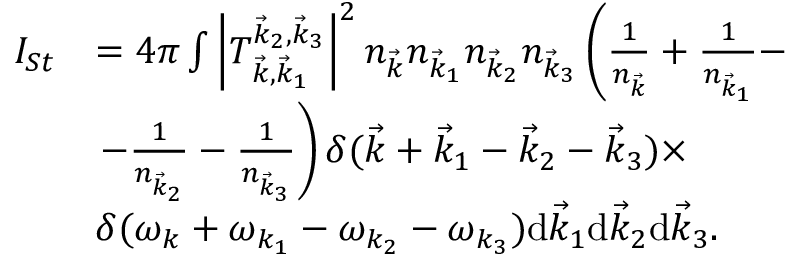Convert formula to latex. <formula><loc_0><loc_0><loc_500><loc_500>\begin{array} { r l } { I _ { S t } } & { = 4 \pi \int \left | T _ { \vec { k } , \vec { k } _ { 1 } } ^ { \vec { k } _ { 2 } , \vec { k } _ { 3 } } \right | ^ { 2 } n _ { \vec { k } } n _ { \vec { k } _ { 1 } } n _ { \vec { k } _ { 2 } } n _ { \vec { k } _ { 3 } } \left ( \frac { 1 } { n _ { \vec { k } } } + \frac { 1 } { n _ { \vec { k } _ { 1 } } } - } \\ & { - \frac { 1 } { n _ { \vec { k } _ { 2 } } } - \frac { 1 } { n _ { \vec { k } _ { 3 } } } \right ) \delta ( \vec { k } + \vec { k } _ { 1 } - \vec { k } _ { 2 } - \vec { k } _ { 3 } ) \times } \\ & { \delta ( \omega _ { k } + \omega _ { k _ { 1 } } - \omega _ { k _ { 2 } } - \omega _ { k _ { 3 } } ) \mathrm d \vec { k } _ { 1 } \mathrm d \vec { k } _ { 2 } \mathrm d \vec { k } _ { 3 } . } \end{array}</formula> 